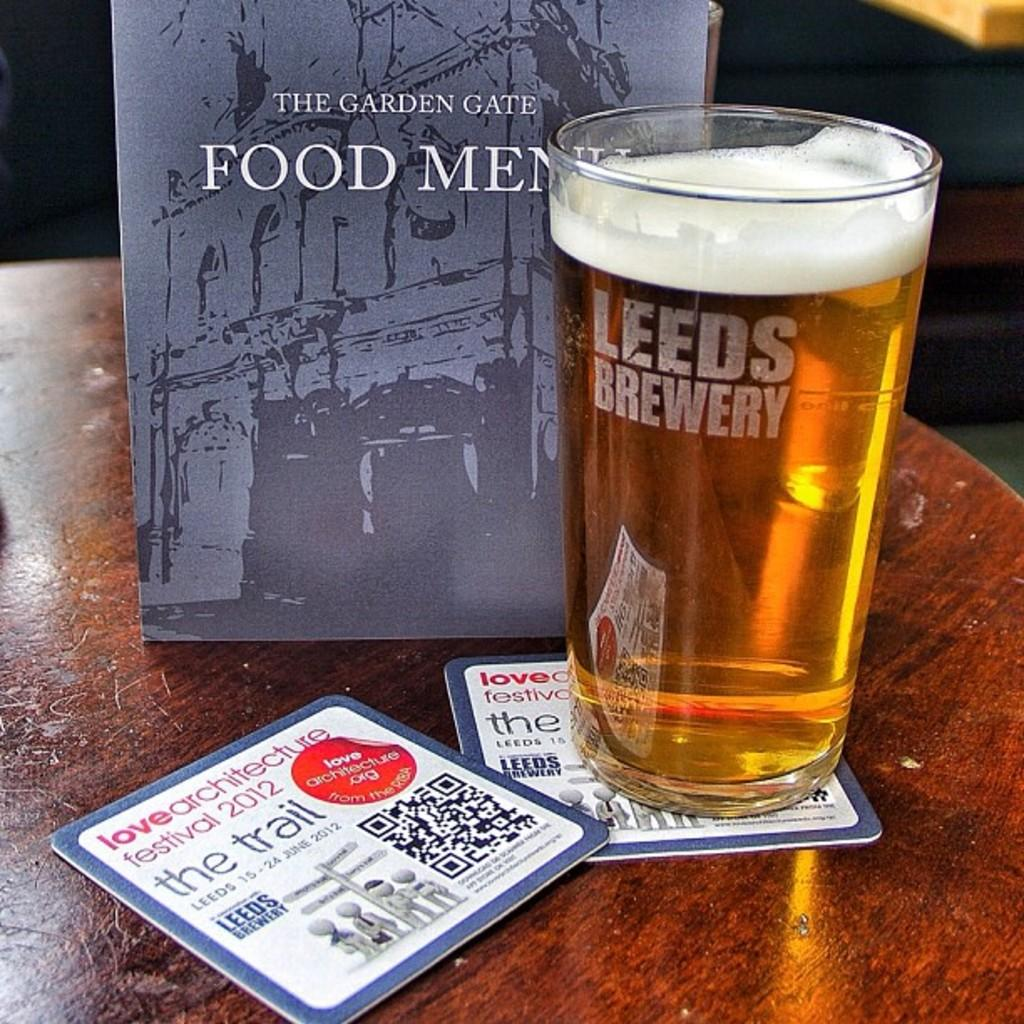What piece of furniture is present in the image? There is a table in the image. What is on the table? There is a glass with beer on the table. What might be used for selecting food or drinks in the image? There is a menu card on the table. What type of grain can be seen growing in the image? There is no grain visible in the image; it features a table with a glass of beer and a menu card. 